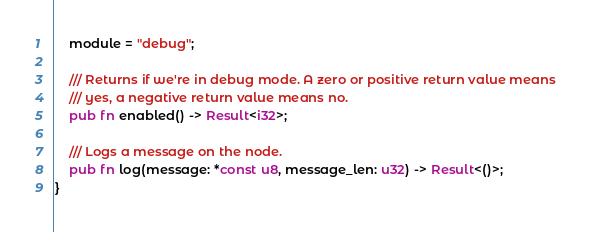Convert code to text. <code><loc_0><loc_0><loc_500><loc_500><_Rust_>    module = "debug";

    /// Returns if we're in debug mode. A zero or positive return value means
    /// yes, a negative return value means no.
    pub fn enabled() -> Result<i32>;

    /// Logs a message on the node.
    pub fn log(message: *const u8, message_len: u32) -> Result<()>;
}
</code> 